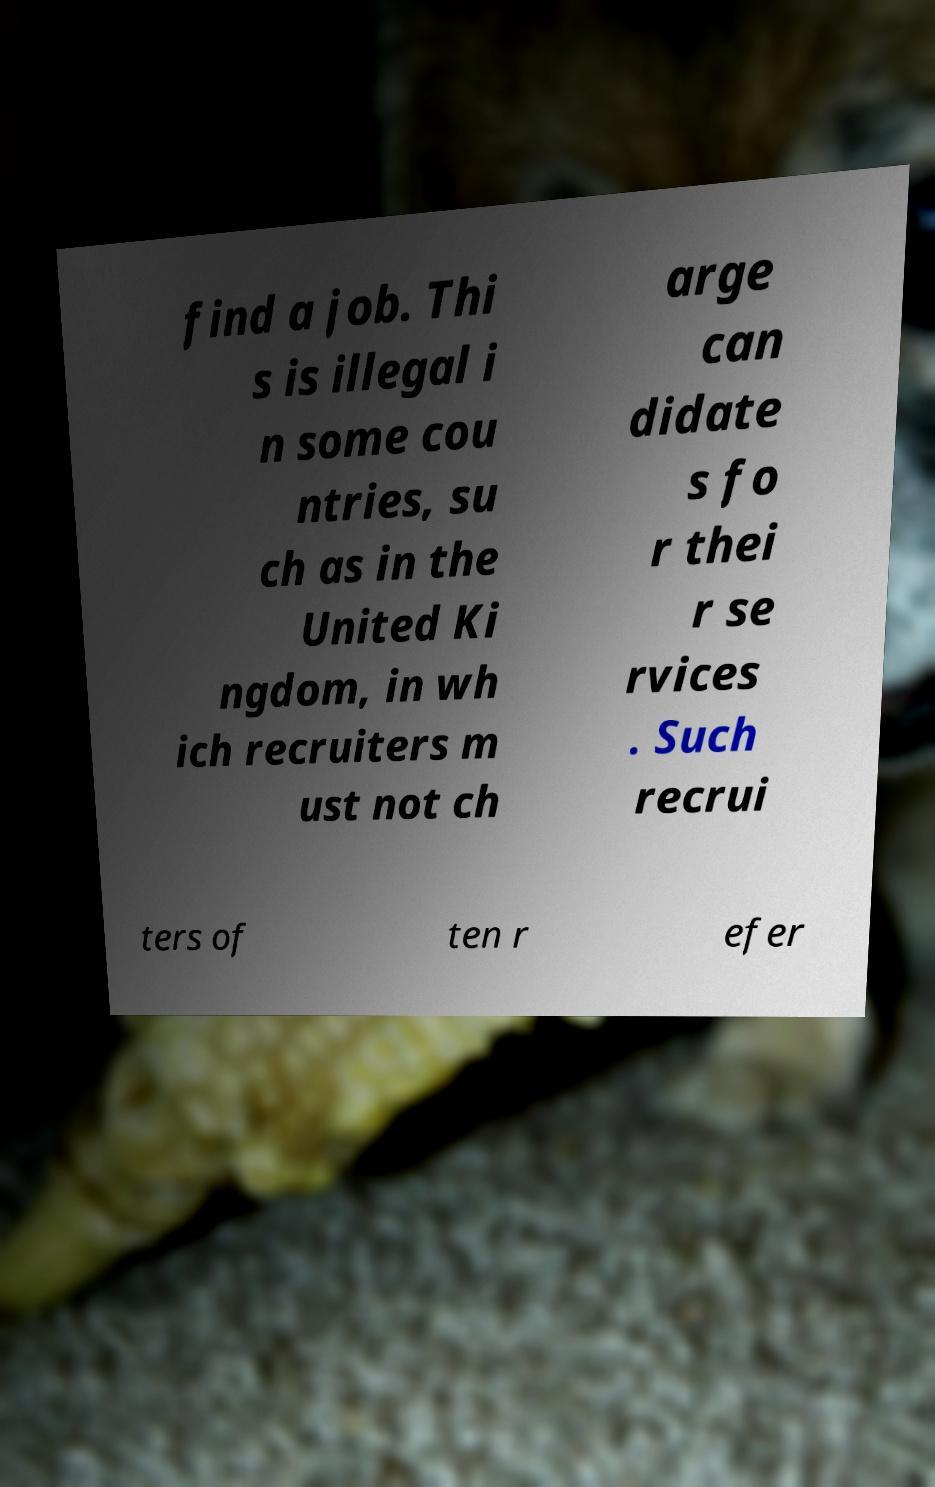Please read and relay the text visible in this image. What does it say? find a job. Thi s is illegal i n some cou ntries, su ch as in the United Ki ngdom, in wh ich recruiters m ust not ch arge can didate s fo r thei r se rvices . Such recrui ters of ten r efer 